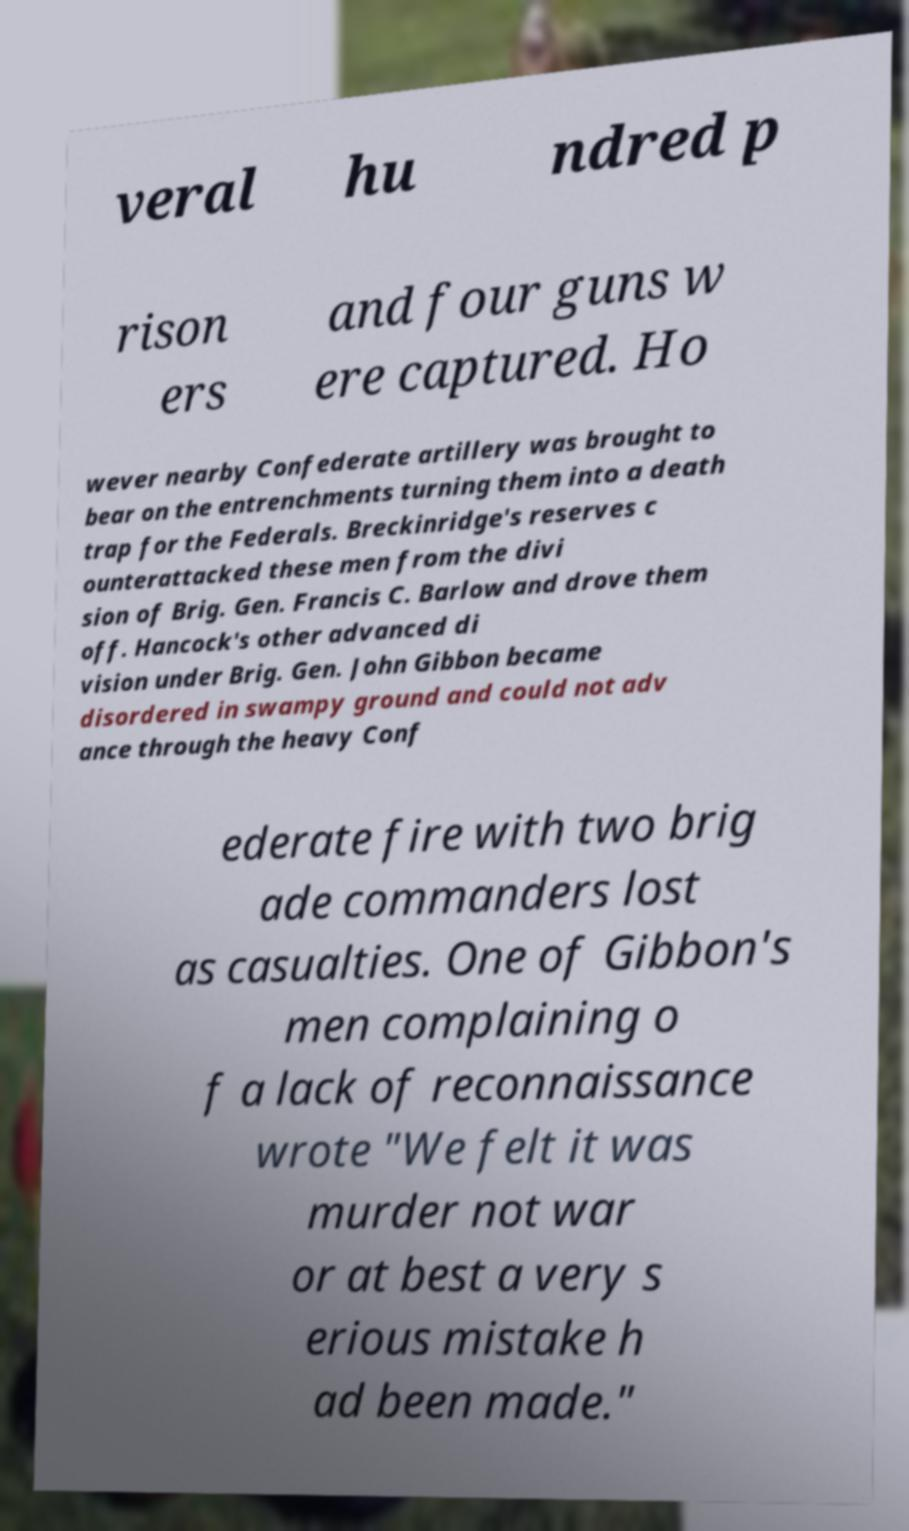Can you read and provide the text displayed in the image?This photo seems to have some interesting text. Can you extract and type it out for me? veral hu ndred p rison ers and four guns w ere captured. Ho wever nearby Confederate artillery was brought to bear on the entrenchments turning them into a death trap for the Federals. Breckinridge's reserves c ounterattacked these men from the divi sion of Brig. Gen. Francis C. Barlow and drove them off. Hancock's other advanced di vision under Brig. Gen. John Gibbon became disordered in swampy ground and could not adv ance through the heavy Conf ederate fire with two brig ade commanders lost as casualties. One of Gibbon's men complaining o f a lack of reconnaissance wrote "We felt it was murder not war or at best a very s erious mistake h ad been made." 